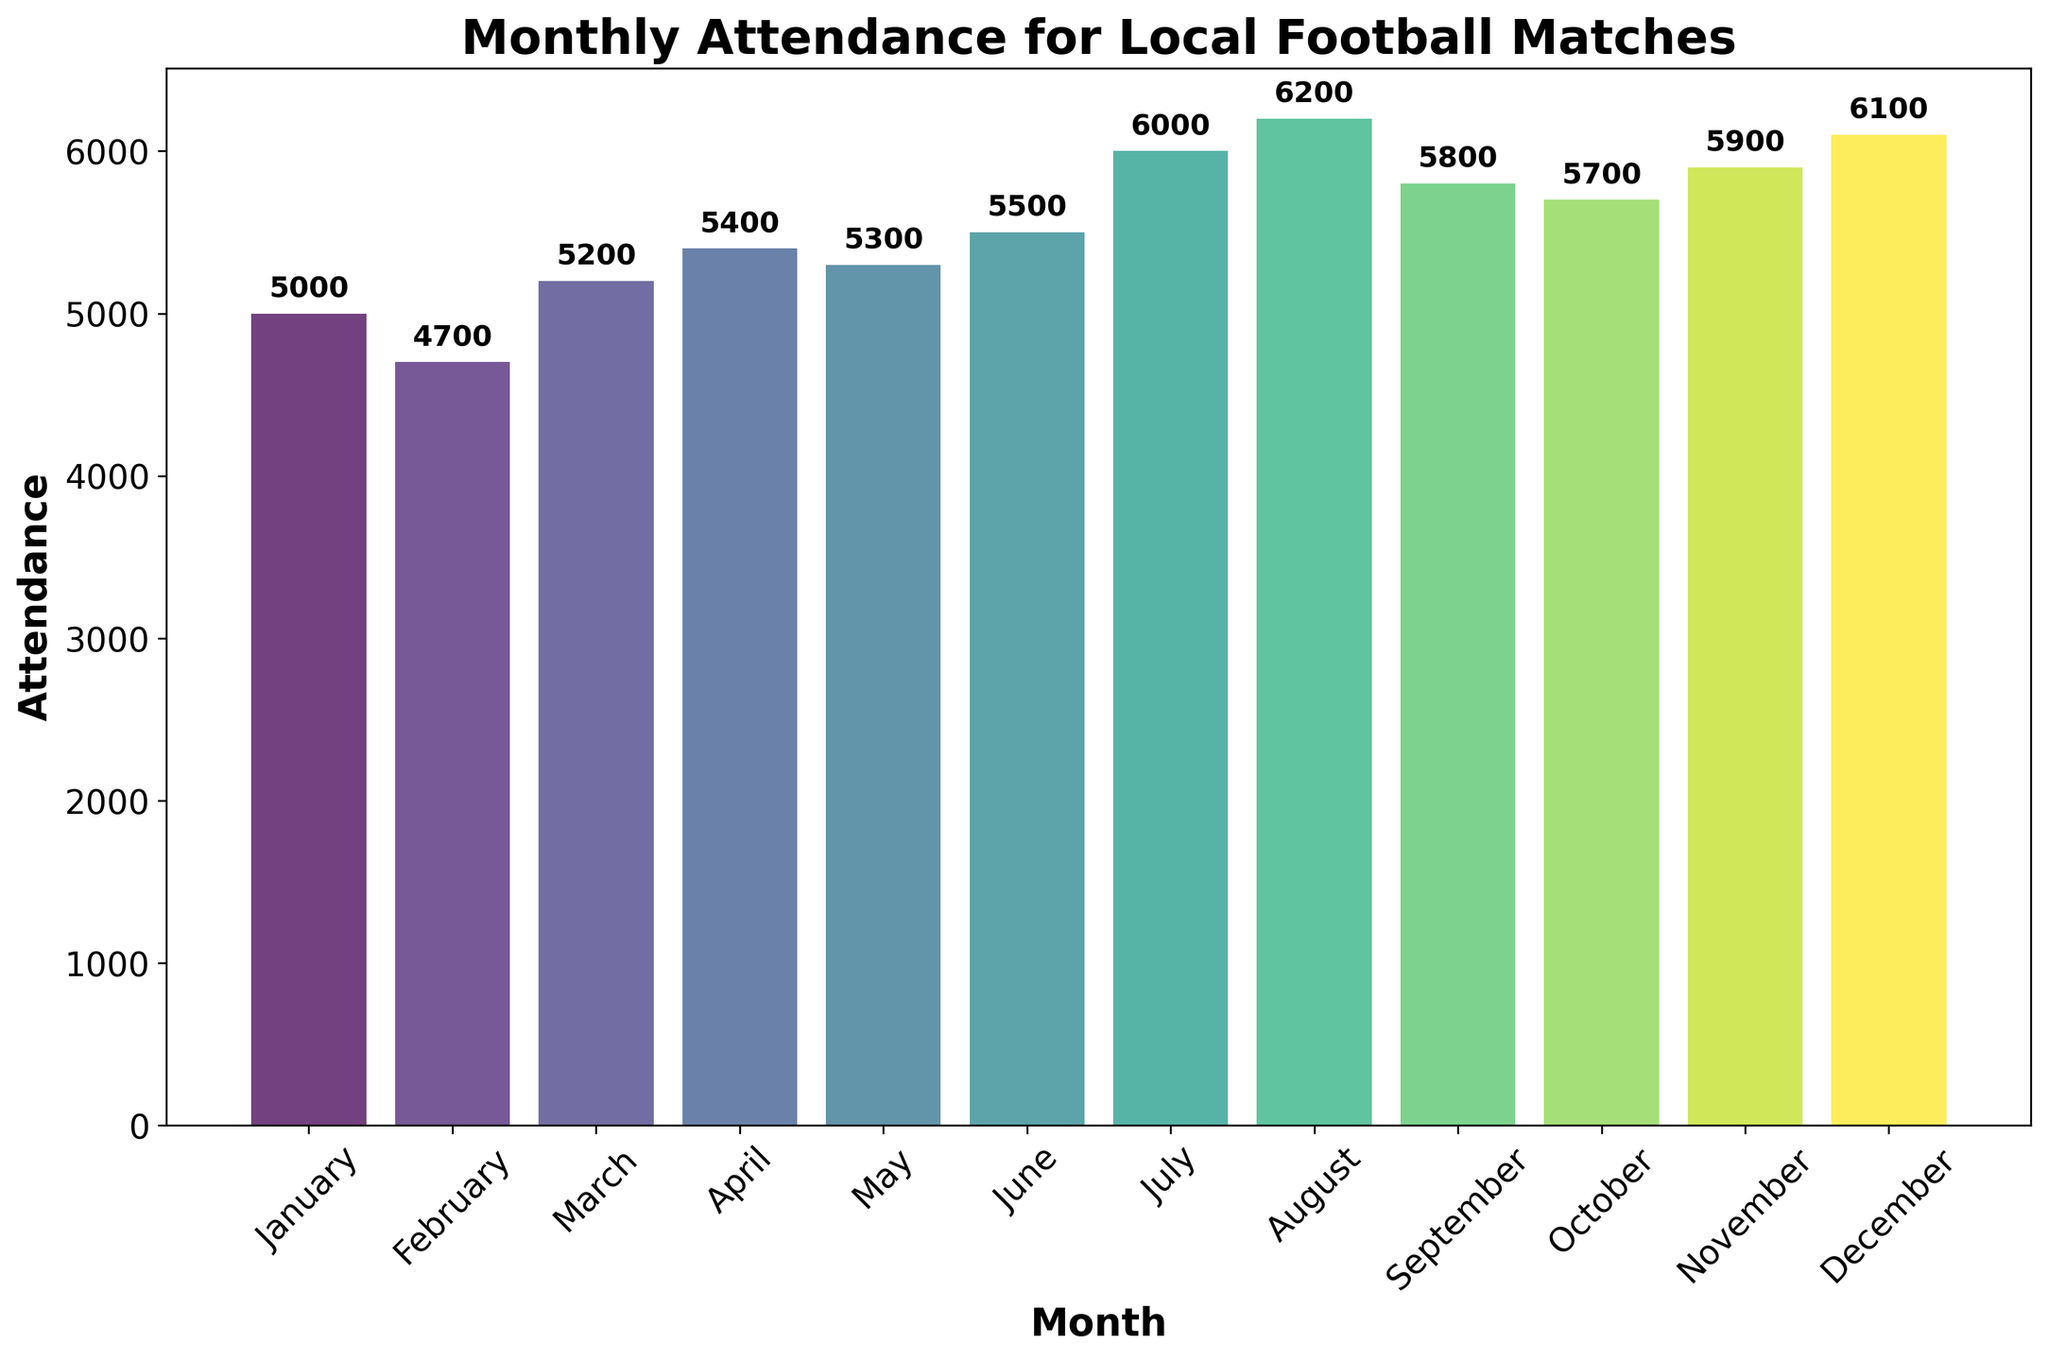Which month had the highest attendance? The bar for August is the tallest, indicating the highest attendance in that month
Answer: August What is the total attendance for January and February combined? The attendance for January is 5000, and for February, it's 4700. Summing these: 5000 + 4700 = 9700
Answer: 9700 Which month had the lowest attendance? The bar for February is the shortest, indicating the lowest attendance in that month
Answer: February Is the attendance in June greater or less than in April? The attendance for June is 5500, and for April, it's 5400. Since 5500 is greater than 5400, June has higher attendance
Answer: Greater What is the difference in attendance between July and September? The attendance for July is 6000, and for September, it's 5800. The difference is 6000 - 5800 = 200
Answer: 200 How does the attendance in May compare to that in October? The attendance for May is 5300, and for October, it's 5700. May's attendance is less than October's
Answer: Less Which season (Winter, Spring, Summer, Autumn) had the highest average attendance? Assign Winter to Dec-Feb, Spring to Mar-May, Summer to Jun-Aug, Autumn to Sep-Nov. Winter: (5000 + 4700 + 6100)/3 = 5266.67, Spring: (5200 + 5400 + 5300)/3 = 5300, Summer: (5500 + 6000 + 6200)/3 = 5900, Autumn: (5800 + 5700 + 5900)/3 = 5800. Summer has the highest average attendance
Answer: Summer What is the average attendance for the entire year? Sum all the monthly attendances (5000 + 4700 + 5200 + 5400 + 5300 + 5500 + 6000 + 6200 + 5800 + 5700 + 5900 + 6100 = 66800). Divide by 12 (months): 66800 / 12 = 5566.67
Answer: 5566.67 How many months had an attendance of 6000 or more? The months with attendance of 6000 or more are July, August, and December. There are 3 such months
Answer: 3 Which months had an attendance between 5500 and 6000? The months with attendance between 5500 and 6000 are June and September
Answer: June, September 